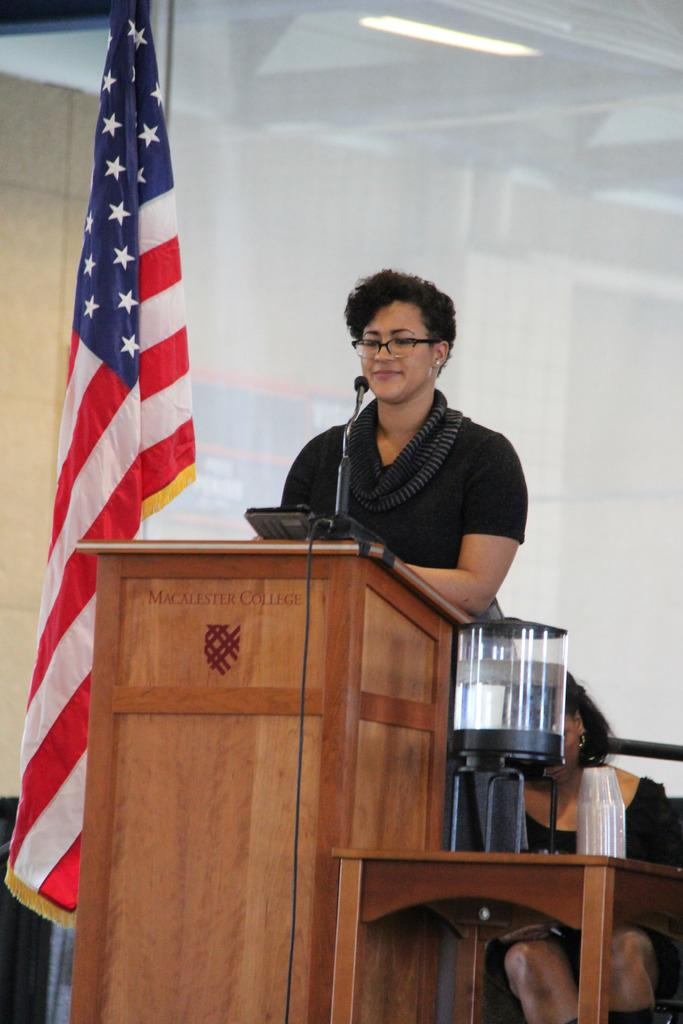<image>
Give a short and clear explanation of the subsequent image. Macalester College is printed in red on the front of a podium. 